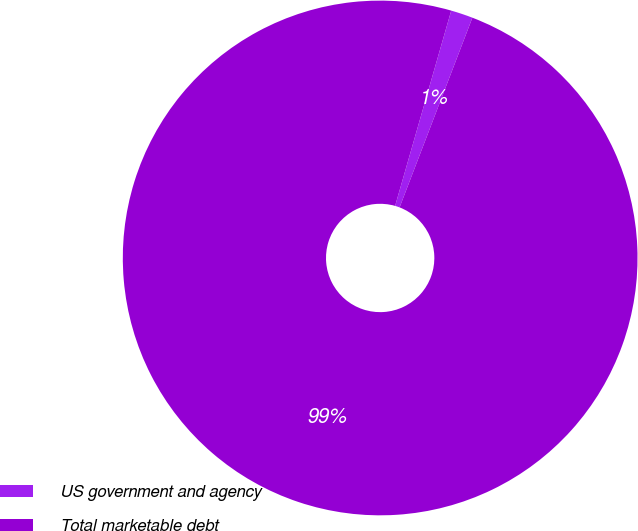<chart> <loc_0><loc_0><loc_500><loc_500><pie_chart><fcel>US government and agency<fcel>Total marketable debt<nl><fcel>1.38%<fcel>98.62%<nl></chart> 